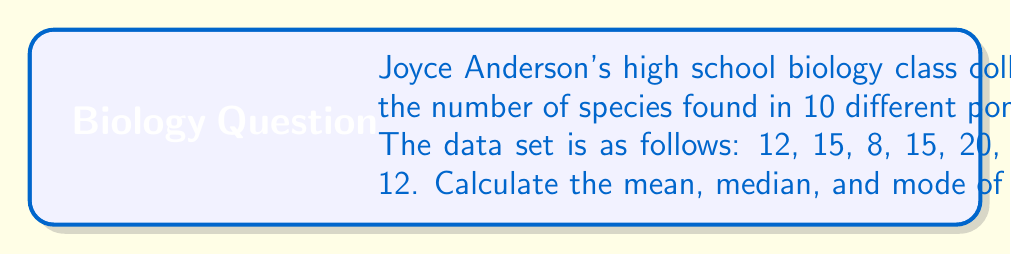What is the answer to this math problem? Let's approach this step-by-step:

1. Mean:
   The mean is the average of all numbers in the dataset.
   
   $$ \text{Mean} = \frac{\sum_{i=1}^{n} x_i}{n} $$
   
   Where $x_i$ are the individual values and $n$ is the total number of values.
   
   $$ \text{Mean} = \frac{12 + 15 + 8 + 15 + 20 + 12 + 8 + 15 + 10 + 12}{10} = \frac{127}{10} = 12.7 $$

2. Median:
   To find the median, first arrange the numbers in ascending order:
   8, 8, 10, 12, 12, 12, 15, 15, 15, 20
   
   With 10 numbers (even), the median is the average of the 5th and 6th numbers.
   
   $$ \text{Median} = \frac{12 + 12}{2} = 12 $$

3. Mode:
   The mode is the value that appears most frequently in the dataset.
   12 and 15 both appear three times, more than any other number.
Answer: Mean: 12.7
Median: 12
Mode: 12 and 15 (bimodal) 